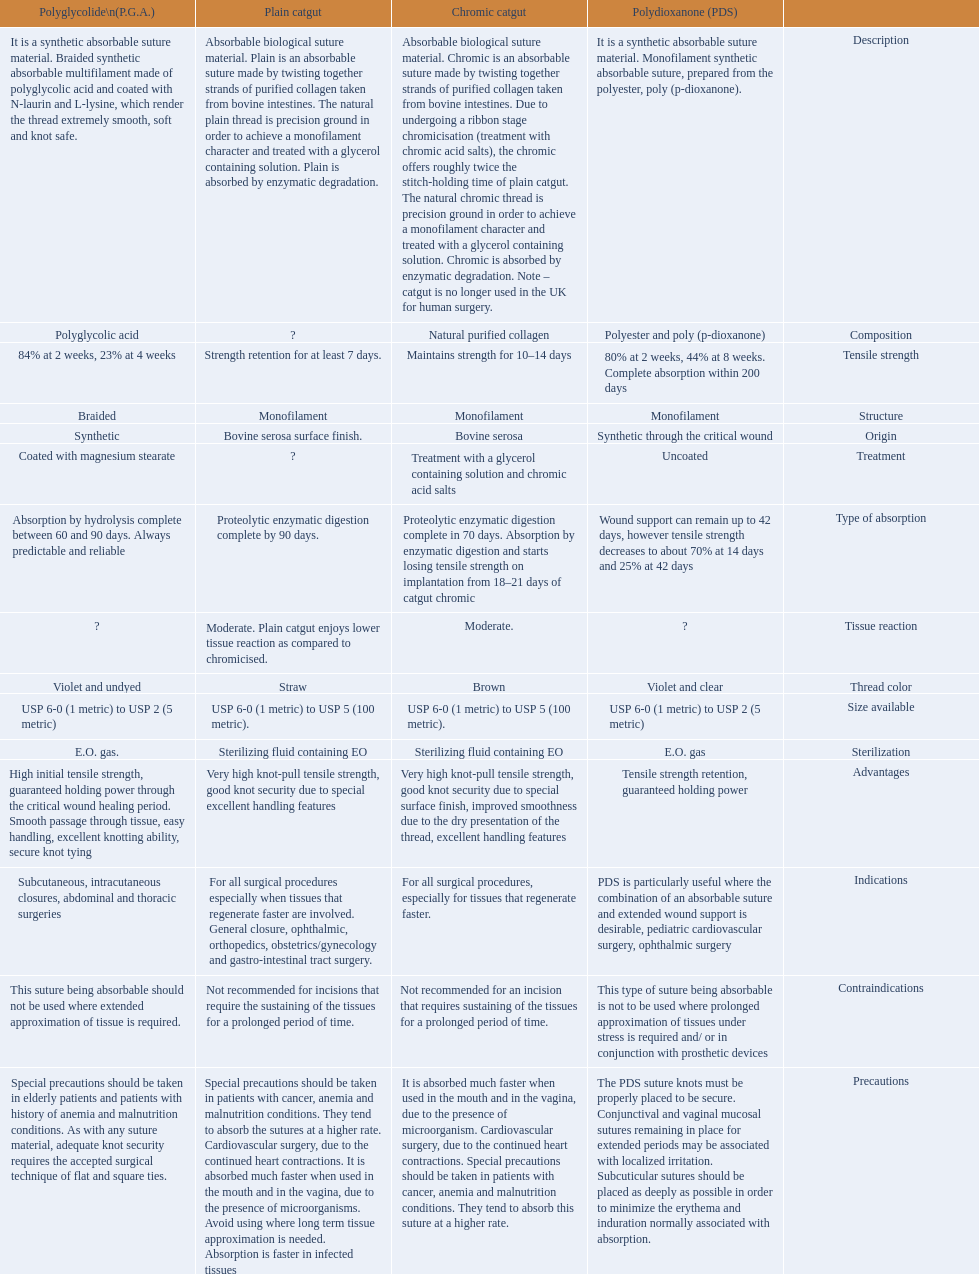What categories are listed in the suture materials comparison chart? Description, Composition, Tensile strength, Structure, Origin, Treatment, Type of absorption, Tissue reaction, Thread color, Size available, Sterilization, Advantages, Indications, Contraindications, Precautions. Of the testile strength, which is the lowest? Strength retention for at least 7 days. 